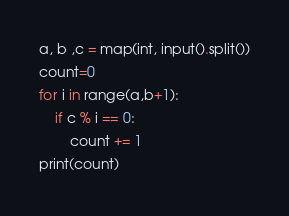Convert code to text. <code><loc_0><loc_0><loc_500><loc_500><_Python_>a, b ,c = map(int, input().split())
count=0
for i in range(a,b+1):
    if c % i == 0:
        count += 1
print(count)
</code> 